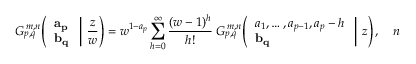Convert formula to latex. <formula><loc_0><loc_0><loc_500><loc_500>G _ { p , q } ^ { \, m , n } \, \left ( { \begin{array} { l } { a _ { p } } \\ { b _ { q } } \end{array} } \, \right | \, { \frac { z } { w } } \right ) = w ^ { 1 - a _ { p } } \sum _ { h = 0 } ^ { \infty } { \frac { ( w - 1 ) ^ { h } } { h ! } } \, G _ { p , q } ^ { \, m , n } \, \left ( { \begin{array} { l } { a _ { 1 } , \dots , a _ { p - 1 } , a _ { p } - h } \\ { b _ { q } } \end{array} } \, \right | \, z \right ) , \quad n</formula> 